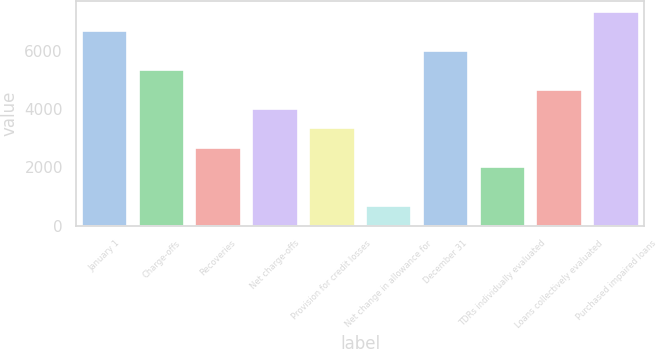Convert chart. <chart><loc_0><loc_0><loc_500><loc_500><bar_chart><fcel>January 1<fcel>Charge-offs<fcel>Recoveries<fcel>Net charge-offs<fcel>Provision for credit losses<fcel>Net change in allowance for<fcel>December 31<fcel>TDRs individually evaluated<fcel>Loans collectively evaluated<fcel>Purchased impaired loans<nl><fcel>6667.03<fcel>5334.17<fcel>2668.45<fcel>4001.31<fcel>3334.88<fcel>669.16<fcel>6000.6<fcel>2002.02<fcel>4667.74<fcel>7333.46<nl></chart> 